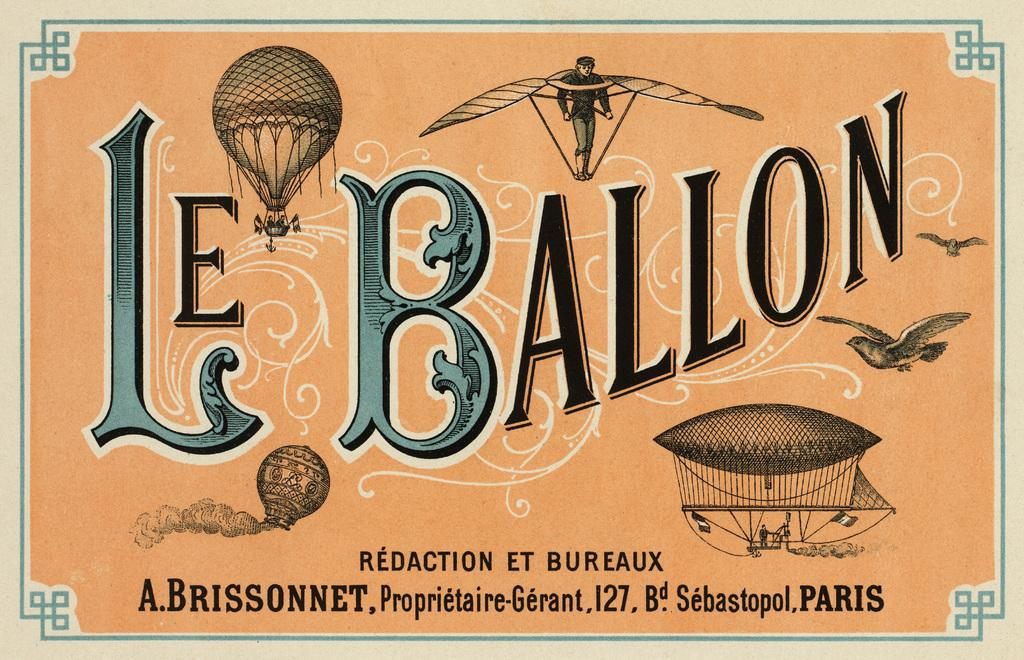<image>
Summarize the visual content of the image. an advertisement with the words le ballon on it 